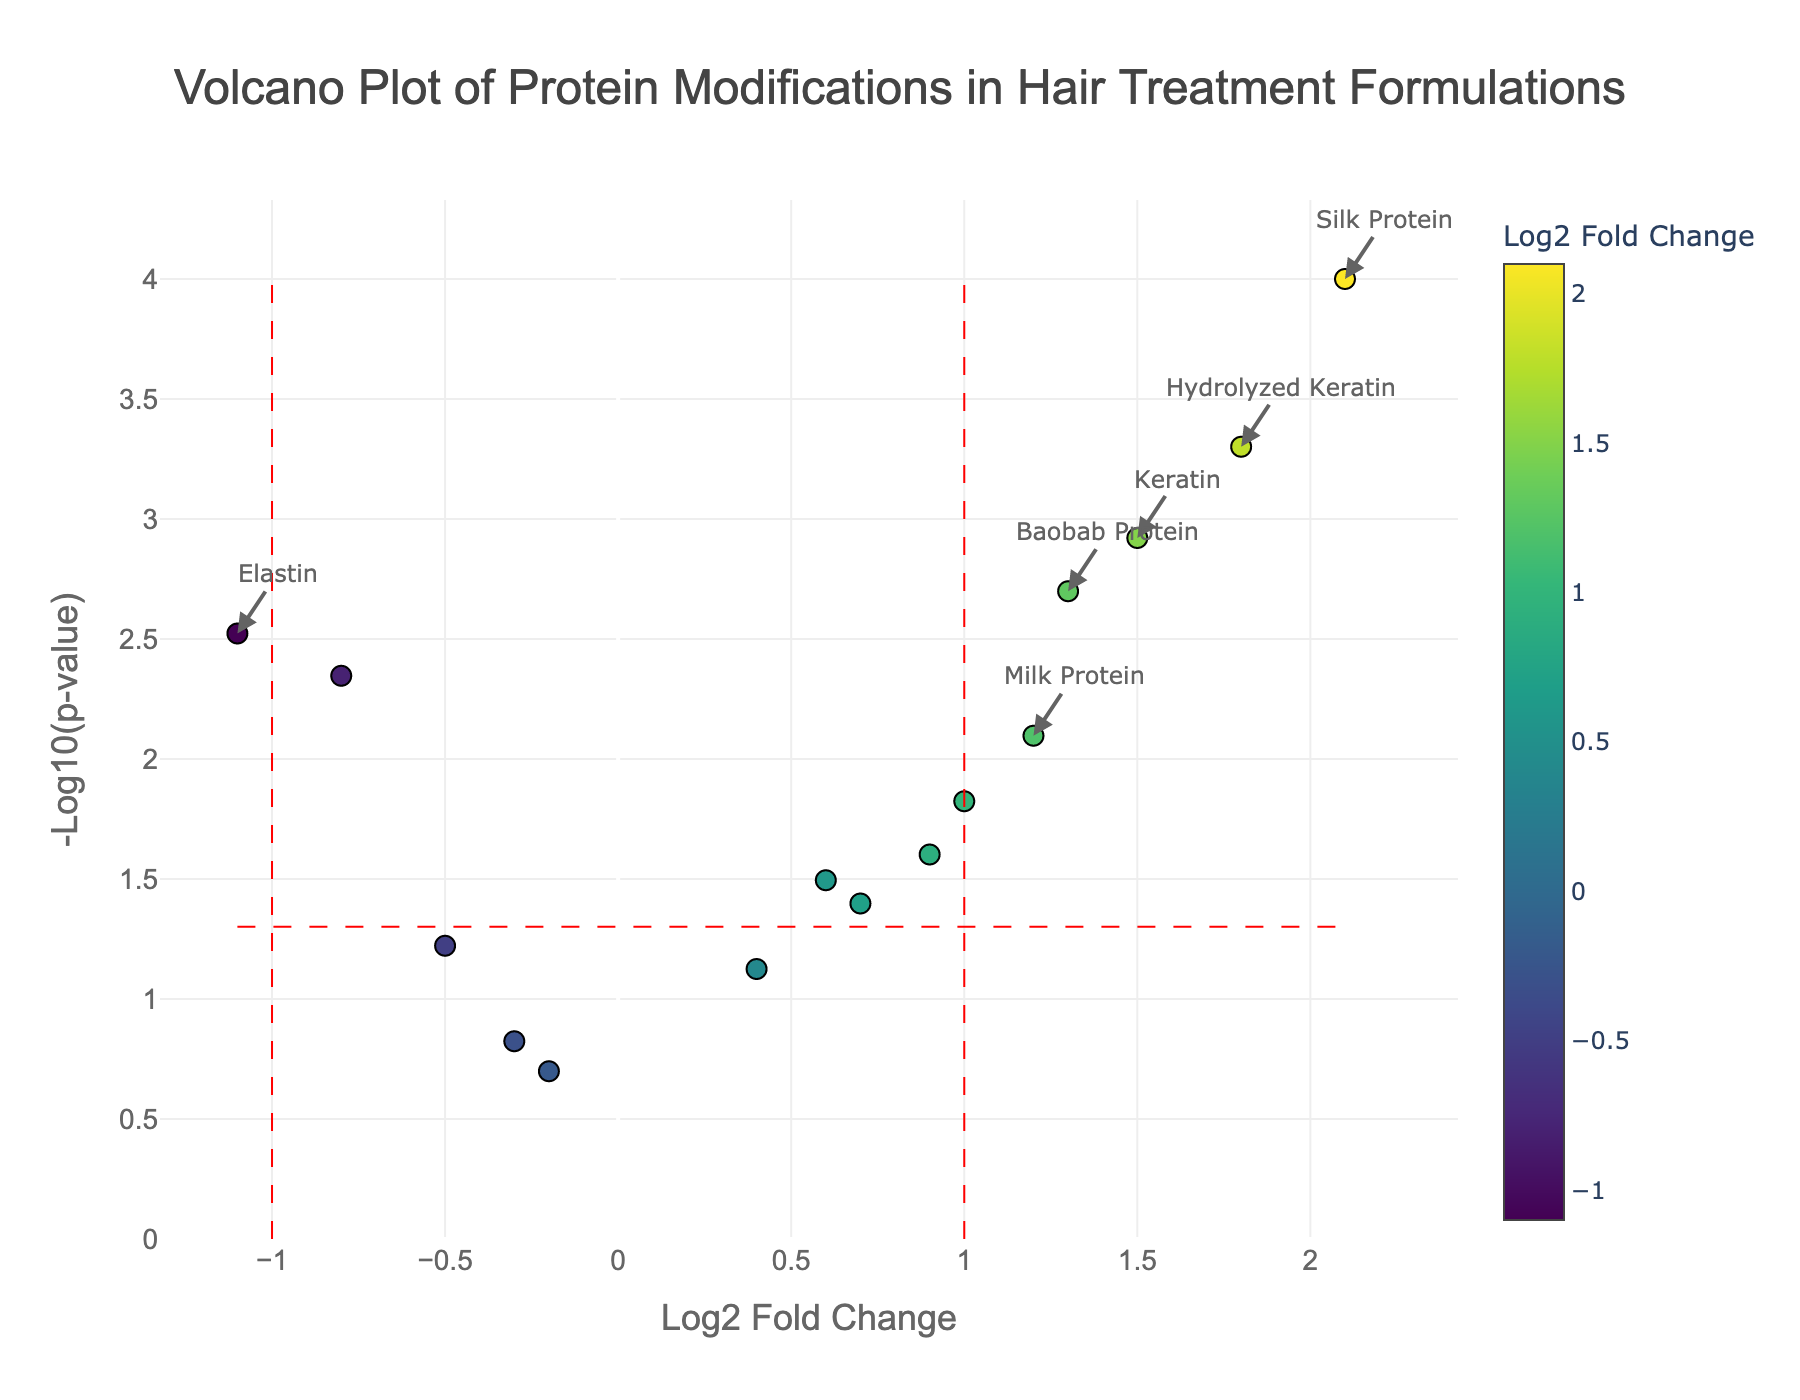Which protein has the highest log2 fold change? The highest point along the x-axis (log2 fold change) indicates the protein with the highest fold change. By examining the plot, the protein with the highest log2 fold change is identified as Silk Protein.
Answer: Silk Protein How many proteins have a p-value less than 0.05? By identifying the points above the red dashed horizontal line (threshold line for p-value 0.05) in the plot, we count the number of proteins. These proteins include Keratin, Collagen, Silk Protein, Wheat Protein, Milk Protein, Quinoa Protein, Elastin, Hydrolyzed Keratin, Rice Protein, Baobab Protein, and Moringa Protein.
Answer: 11 Which protein has the most negative log2 fold change? By examining the plot, the most leftward point along the x-axis (log2 fold change) indicates the protein with the most negative value. This protein is Elastin.
Answer: Elastin What is the log2 fold change and p-value for Hydrolyzed Keratin? By inspecting the plotted points and their annotations, it can be observed that Hydrolyzed Keratin has a log2 fold change of 1.8 and a p-value of 0.0005.
Answer: log2 fold change: 1.8, p-value: 0.0005 What is the significance threshold for p-values represented in the plot? The significance threshold line for p-values is drawn horizontally at -log10(0.05). Therefore, the significance threshold for p-values is 0.05.
Answer: 0.05 Which proteins are labeled as significant in the plot? Proteins that have absolute log2 fold change values greater than 1 and p-values less than 0.05 are labeled. By examining the plot, these proteins are Keratin, Silk Protein, Hydrolyzed Keratin, and Baobab Protein.
Answer: Keratin, Silk Protein, Hydrolyzed Keratin, Baobab Protein How many proteins have a log2 fold change within the range of -1 to 1? To find this, we count the points within the range of -1 to 1 along the x-axis. These include Collagen, Wheat Protein, Soy Protein, Oat Protein, Pea Protein, Rice Protein, Quinoa Protein, Argan Protein, and Moringa Protein.
Answer: 9 Which protein has the smallest p-value? By locating the highest point along the y-axis (-log10(p-value)) on the plot, we find the protein with the smallest p-value. This protein is Silk Protein.
Answer: Silk Protein 